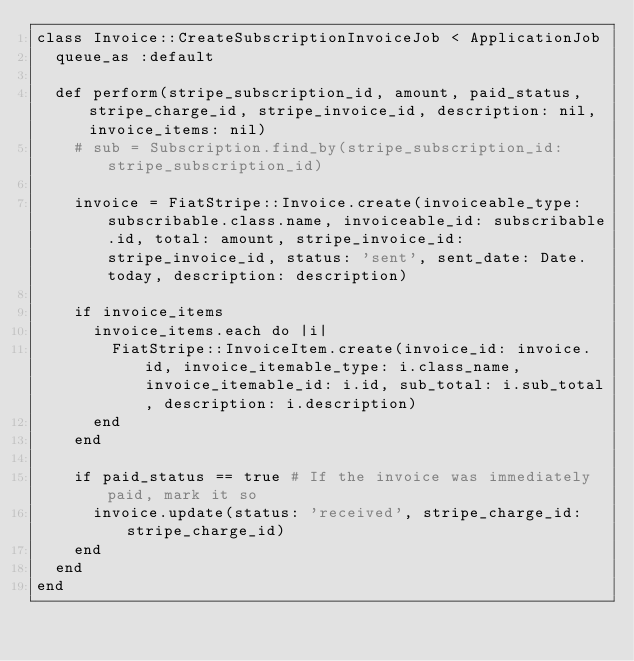Convert code to text. <code><loc_0><loc_0><loc_500><loc_500><_Ruby_>class Invoice::CreateSubscriptionInvoiceJob < ApplicationJob
  queue_as :default

  def perform(stripe_subscription_id, amount, paid_status, stripe_charge_id, stripe_invoice_id, description: nil, invoice_items: nil)
    # sub = Subscription.find_by(stripe_subscription_id: stripe_subscription_id)

    invoice = FiatStripe::Invoice.create(invoiceable_type: subscribable.class.name, invoiceable_id: subscribable.id, total: amount, stripe_invoice_id: stripe_invoice_id, status: 'sent', sent_date: Date.today, description: description)

    if invoice_items
      invoice_items.each do |i|
        FiatStripe::InvoiceItem.create(invoice_id: invoice.id, invoice_itemable_type: i.class_name, invoice_itemable_id: i.id, sub_total: i.sub_total, description: i.description)
      end
    end

    if paid_status == true # If the invoice was immediately paid, mark it so
      invoice.update(status: 'received', stripe_charge_id: stripe_charge_id)
    end
  end
end
</code> 